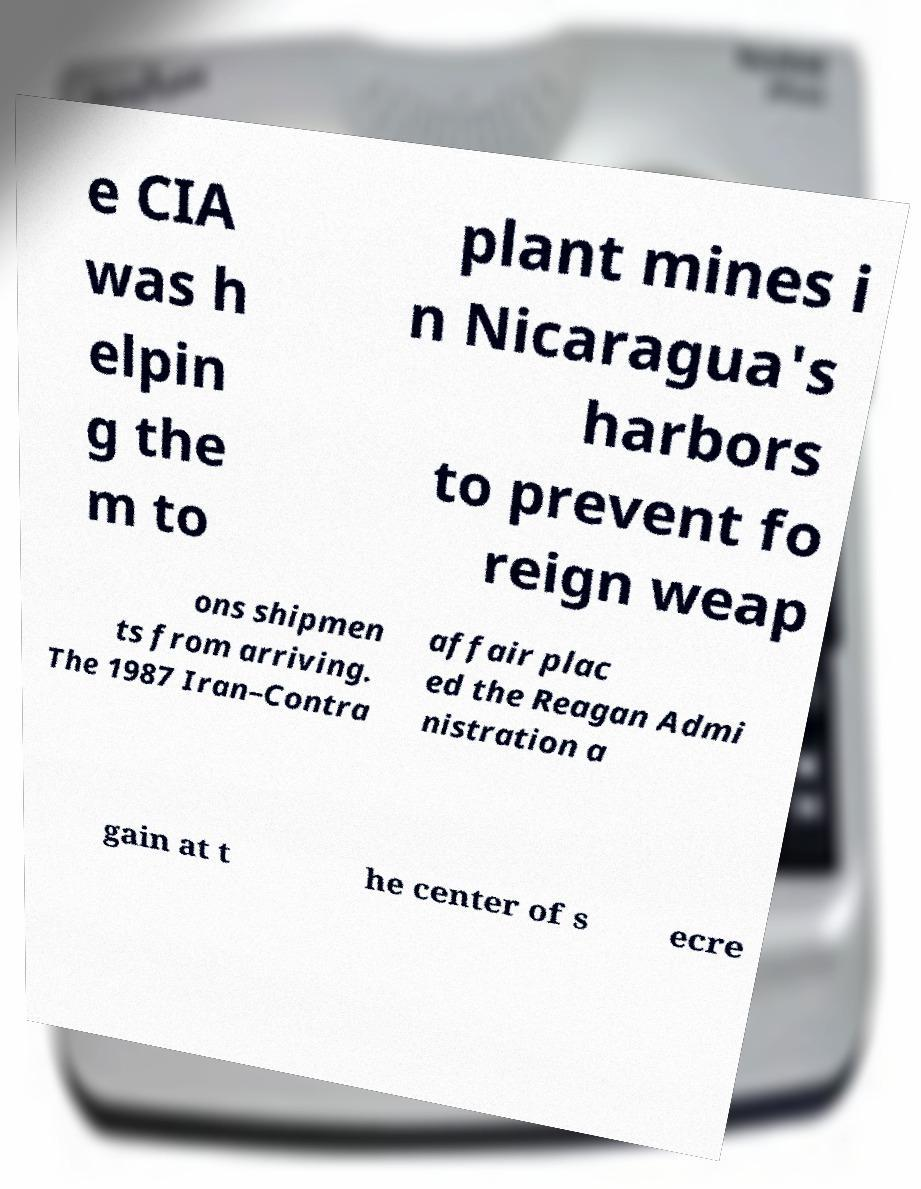There's text embedded in this image that I need extracted. Can you transcribe it verbatim? e CIA was h elpin g the m to plant mines i n Nicaragua's harbors to prevent fo reign weap ons shipmen ts from arriving. The 1987 Iran–Contra affair plac ed the Reagan Admi nistration a gain at t he center of s ecre 